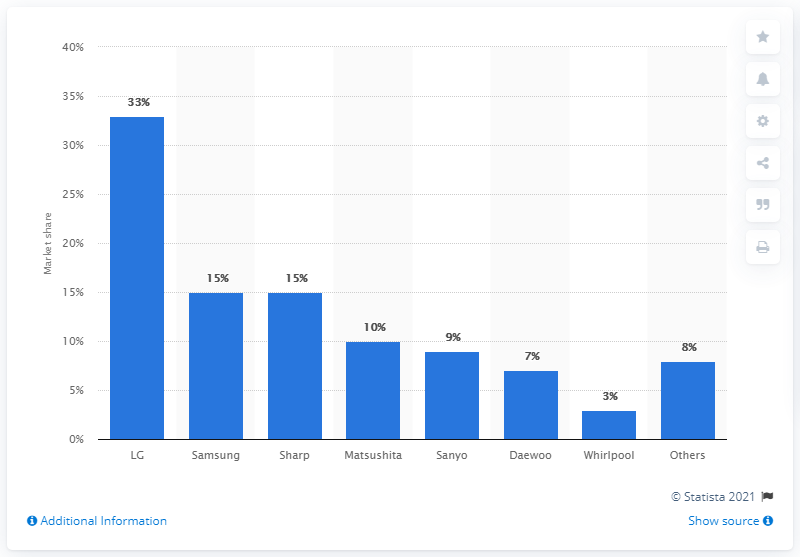Point out several critical features in this image. In 2008, Samsung held 15% of the microwave oven market in the United States. 